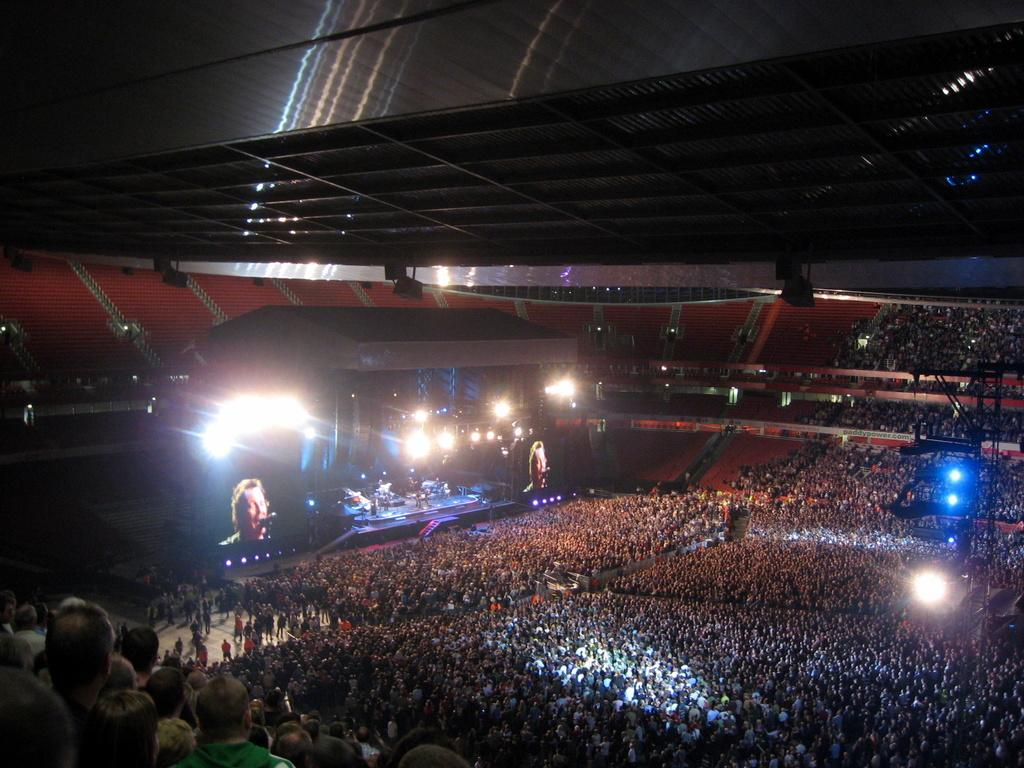How many people are in the image? There is a group of people in the image, but the exact number cannot be determined from the provided facts. What can be seen illuminated in the image? There are lights visible in the image. What type of structure is present in the image? There is a roof in the image. What type of silk is being used to create the texture of the ink in the image? There is no silk or ink present in the image, so this question cannot be answered. 